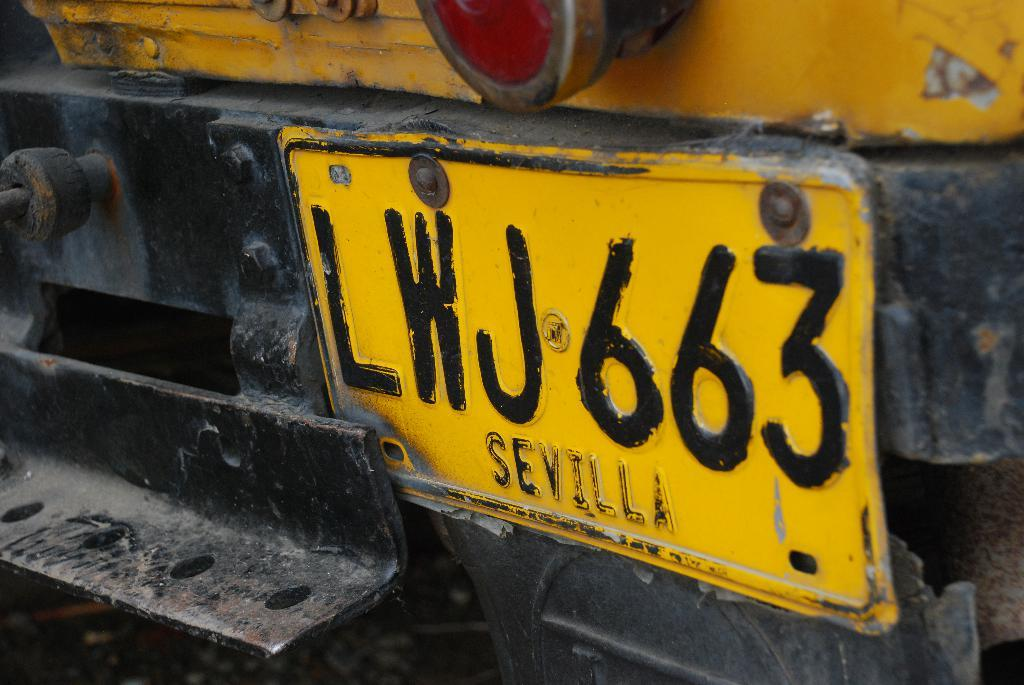<image>
Describe the image concisely. the license plate of a vehicle that is LWJ663 